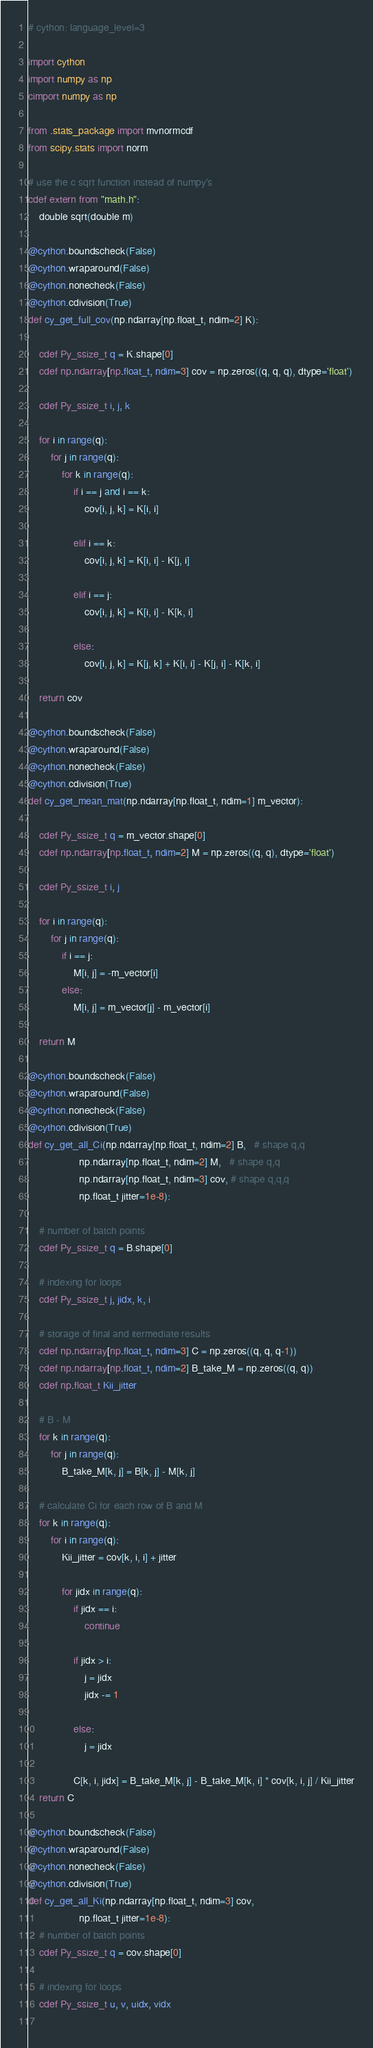<code> <loc_0><loc_0><loc_500><loc_500><_Cython_># cython: language_level=3

import cython
import numpy as np
cimport numpy as np

from .stats_package import mvnormcdf
from scipy.stats import norm

# use the c sqrt function instead of numpy's
cdef extern from "math.h":
    double sqrt(double m)
    
@cython.boundscheck(False)
@cython.wraparound(False)
@cython.nonecheck(False)
@cython.cdivision(True)
def cy_get_full_cov(np.ndarray[np.float_t, ndim=2] K):
    
    cdef Py_ssize_t q = K.shape[0]
    cdef np.ndarray[np.float_t, ndim=3] cov = np.zeros((q, q, q), dtype='float')
    
    cdef Py_ssize_t i, j, k
    
    for i in range(q):
        for j in range(q):
            for k in range(q):
                if i == j and i == k:
                    cov[i, j, k] = K[i, i]
                    
                elif i == k:
                    cov[i, j, k] = K[i, i] - K[j, i]
                    
                elif i == j:
                    cov[i, j, k] = K[i, i] - K[k, i]
                    
                else:
                    cov[i, j, k] = K[j, k] + K[i, i] - K[j, i] - K[k, i]

    return cov
    
@cython.boundscheck(False)
@cython.wraparound(False)
@cython.nonecheck(False)
@cython.cdivision(True)
def cy_get_mean_mat(np.ndarray[np.float_t, ndim=1] m_vector):
    
    cdef Py_ssize_t q = m_vector.shape[0]
    cdef np.ndarray[np.float_t, ndim=2] M = np.zeros((q, q), dtype='float')
    
    cdef Py_ssize_t i, j
    
    for i in range(q):
        for j in range(q):
            if i == j:
                M[i, j] = -m_vector[i]
            else:
                M[i, j] = m_vector[j] - m_vector[i]
                
    return M
    
@cython.boundscheck(False)
@cython.wraparound(False)
@cython.nonecheck(False)
@cython.cdivision(True)
def cy_get_all_Ci(np.ndarray[np.float_t, ndim=2] B,   # shape q,q
                  np.ndarray[np.float_t, ndim=2] M,   # shape q,q
                  np.ndarray[np.float_t, ndim=3] cov, # shape q,q,q
                  np.float_t jitter=1e-8): 
    
    # number of batch points
    cdef Py_ssize_t q = B.shape[0]
    
    # indexing for loops
    cdef Py_ssize_t j, jidx, k, i
    
    # storage of final and itermediate results
    cdef np.ndarray[np.float_t, ndim=3] C = np.zeros((q, q, q-1))
    cdef np.ndarray[np.float_t, ndim=2] B_take_M = np.zeros((q, q))
    cdef np.float_t Kii_jitter
    
    # B - M
    for k in range(q):
        for j in range(q):
            B_take_M[k, j] = B[k, j] - M[k, j]
    
    # calculate Ci for each row of B and M
    for k in range(q):
        for i in range(q):
            Kii_jitter = cov[k, i, i] + jitter
            
            for jidx in range(q):
                if jidx == i:
                    continue

                if jidx > i:
                    j = jidx
                    jidx -= 1

                else:
                    j = jidx

                C[k, i, jidx] = B_take_M[k, j] - B_take_M[k, i] * cov[k, i, j] / Kii_jitter
    return C
    
@cython.boundscheck(False)
@cython.wraparound(False)
@cython.nonecheck(False)
@cython.cdivision(True)
def cy_get_all_Ki(np.ndarray[np.float_t, ndim=3] cov,
                  np.float_t jitter=1e-8):
    # number of batch points
    cdef Py_ssize_t q = cov.shape[0]
    
    # indexing for loops
    cdef Py_ssize_t u, v, uidx, vidx
    </code> 